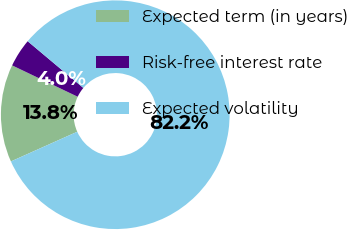Convert chart. <chart><loc_0><loc_0><loc_500><loc_500><pie_chart><fcel>Expected term (in years)<fcel>Risk-free interest rate<fcel>Expected volatility<nl><fcel>13.8%<fcel>4.01%<fcel>82.19%<nl></chart> 